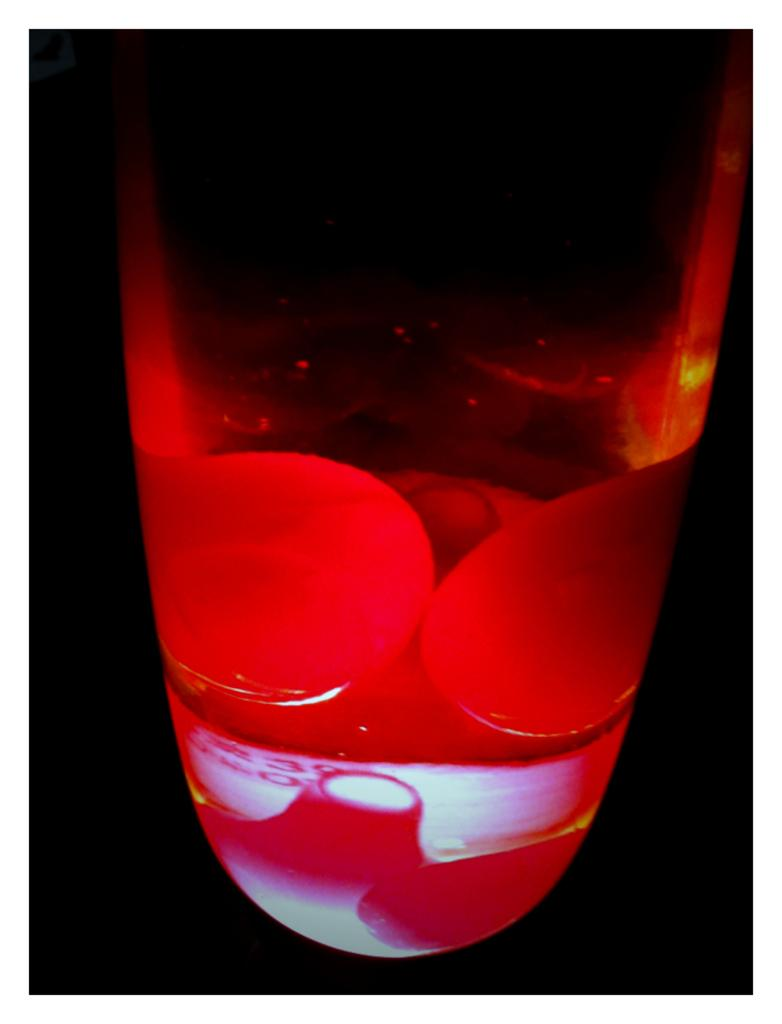What is present in the image that provides illumination? There is a light in the image. How would you describe the lighting conditions at the bottom of the image? The bottom of the image is dark. How many trees can be seen in the image? There are no trees present in the image. What type of sheep can be seen grazing in the image? There are no sheep present in the image. 